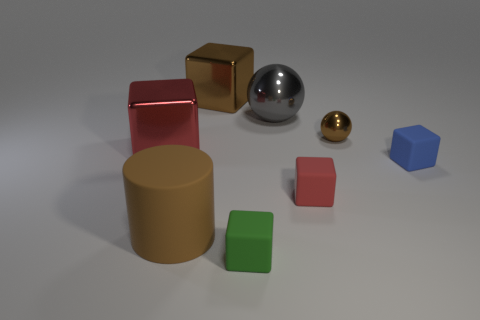Does the brown metal object left of the small green matte thing have the same shape as the large red shiny thing?
Keep it short and to the point. Yes. The large brown object in front of the large metallic thing left of the metallic cube behind the tiny ball is what shape?
Your response must be concise. Cylinder. What is the shape of the big metallic thing that is the same color as the large cylinder?
Offer a very short reply. Cube. The object that is to the right of the large matte thing and in front of the red rubber object is made of what material?
Your response must be concise. Rubber. Are there fewer spheres than tiny brown spheres?
Offer a terse response. No. Do the gray metal object and the matte object that is to the left of the green object have the same shape?
Your answer should be very brief. No. Do the red thing to the left of the matte cylinder and the tiny red rubber cube have the same size?
Provide a succinct answer. No. There is a red shiny thing that is the same size as the brown matte cylinder; what shape is it?
Provide a succinct answer. Cube. Is the shape of the big red thing the same as the green object?
Keep it short and to the point. Yes. What number of large brown shiny things have the same shape as the tiny green matte thing?
Ensure brevity in your answer.  1. 